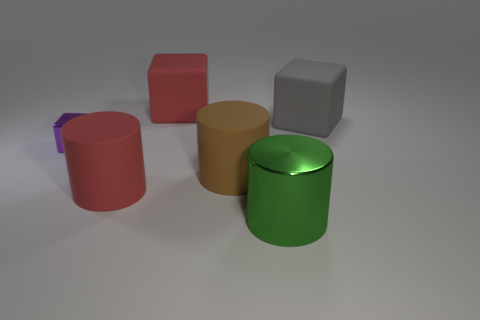What is the material of the small purple block?
Your answer should be very brief. Metal. How many blocks are either big green metallic objects or cyan metal objects?
Give a very brief answer. 0. Is the red cylinder made of the same material as the purple block?
Offer a very short reply. No. What is the size of the red rubber thing that is the same shape as the small shiny object?
Your answer should be very brief. Large. There is a large object that is both to the right of the large brown cylinder and in front of the gray cube; what is it made of?
Make the answer very short. Metal. Is the number of large gray rubber blocks that are to the right of the big metallic object the same as the number of big purple rubber balls?
Your answer should be compact. No. How many objects are big objects that are behind the tiny purple cube or green objects?
Offer a terse response. 3. What is the size of the matte cylinder that is in front of the big brown matte cylinder?
Ensure brevity in your answer.  Large. What is the shape of the metal object to the left of the large red object that is in front of the tiny purple thing?
Keep it short and to the point. Cube. What is the color of the other large thing that is the same shape as the gray object?
Give a very brief answer. Red. 